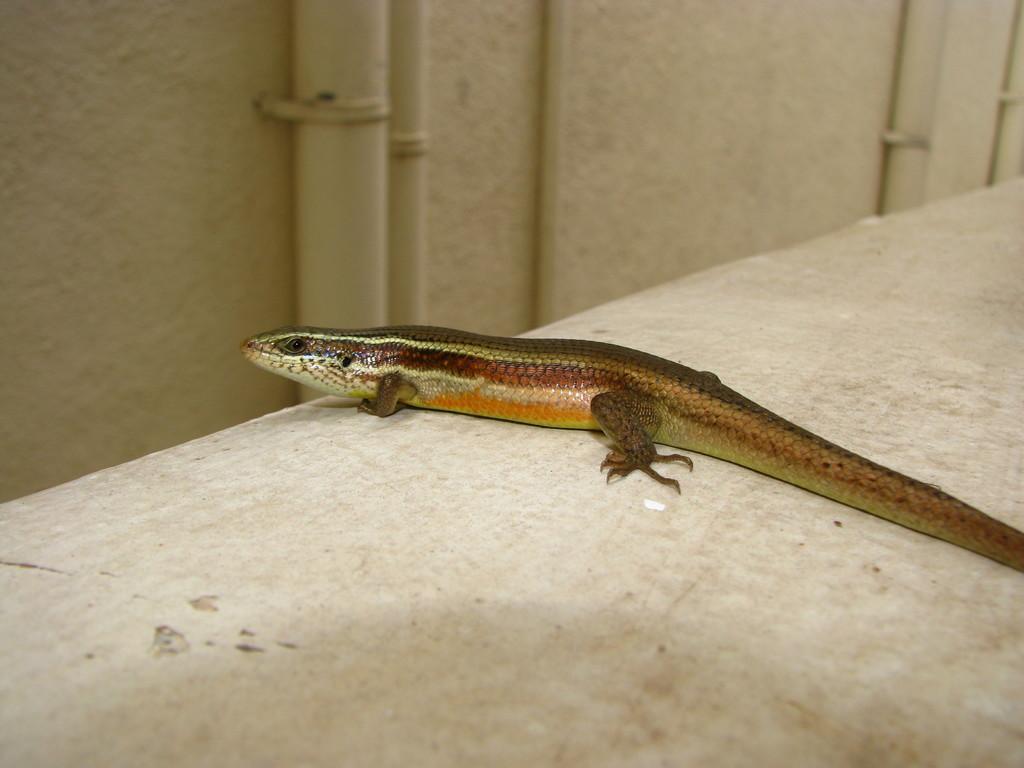Could you give a brief overview of what you see in this image? There is a reptile on a white color surface, In the background there is a pipe attached to the wall. 